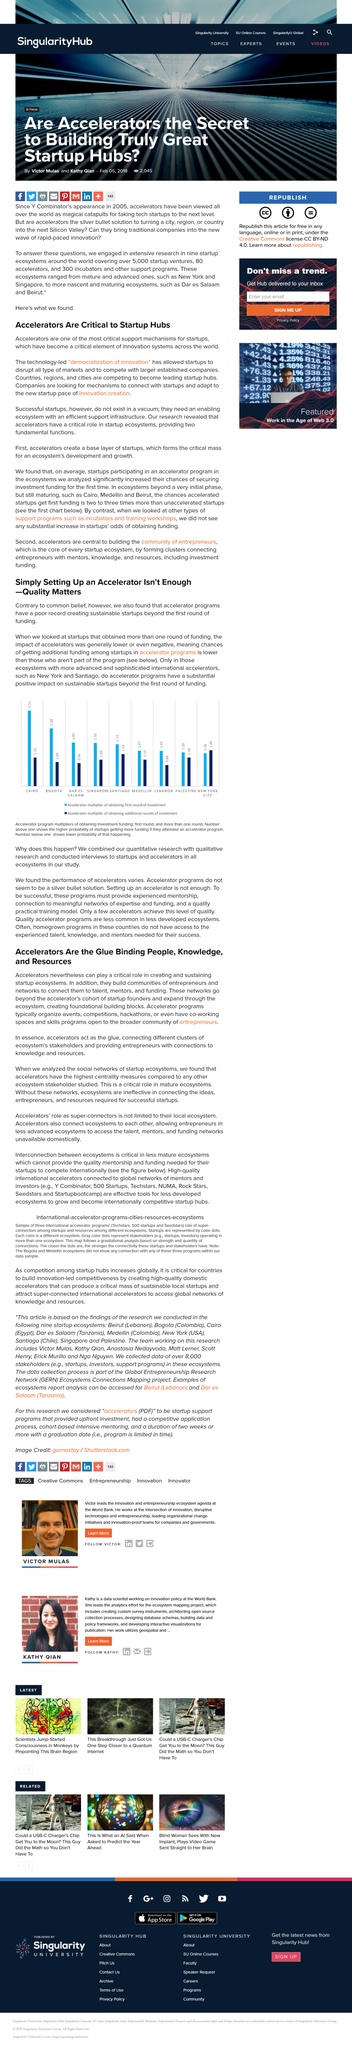Highlight a few significant elements in this photo. There are several locations competing to become leading startup hubs, including countries, regions, and cities, each offering unique opportunities and challenges for innovation and growth. In general, accelerator programs do not perform well when used in the early stages of funding a startup. Yes, accelerators connect different clusters of ecosystem's stakeholders. After the first round of funding, accelerator programs have a history of failing to create sustainable startups, as evidenced by their poor record. Accelerators provide entrepreneurs with connections to knowledge and resources, enabling them to access valuable information and resources that contribute to the success of their businesses. 